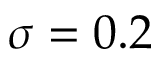<formula> <loc_0><loc_0><loc_500><loc_500>\sigma = 0 . 2</formula> 